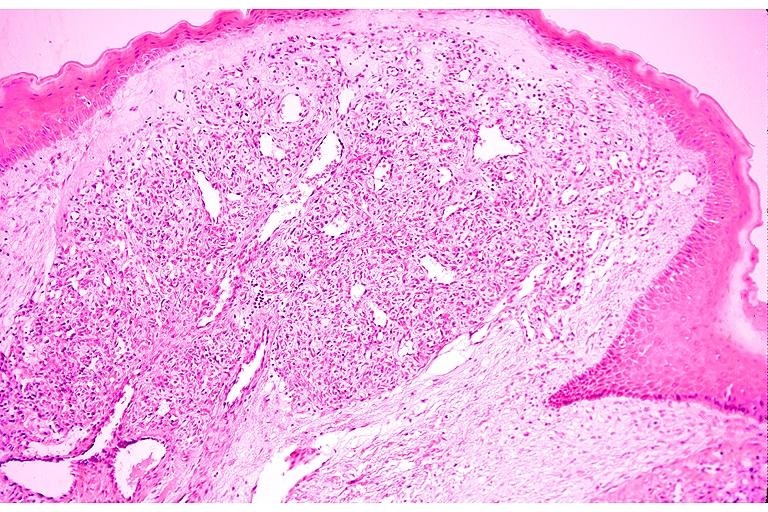s oral present?
Answer the question using a single word or phrase. Yes 